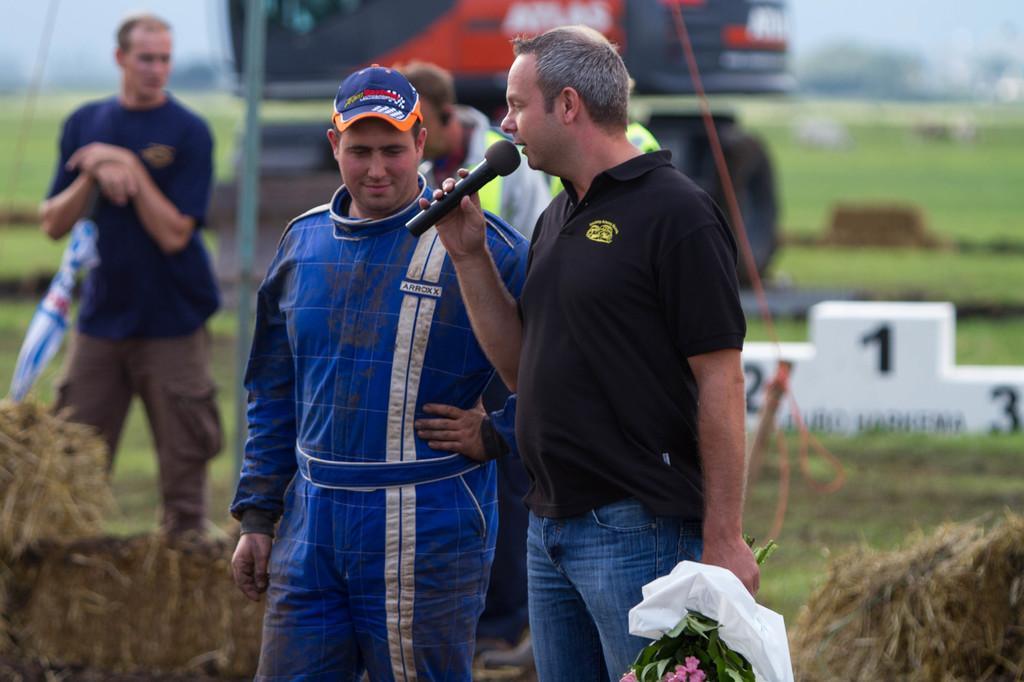Could you give a brief overview of what you see in this image? In this picture I can observe some people standing on the land. One of them is holding a mic in his hand. The background is blurred. 